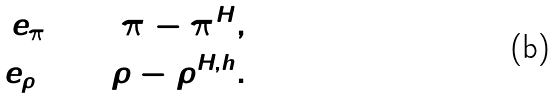<formula> <loc_0><loc_0><loc_500><loc_500>e _ { \pi } \colon = \pi - \pi ^ { H } , \\ e _ { \rho } \colon = \rho - \rho ^ { H , h } .</formula> 